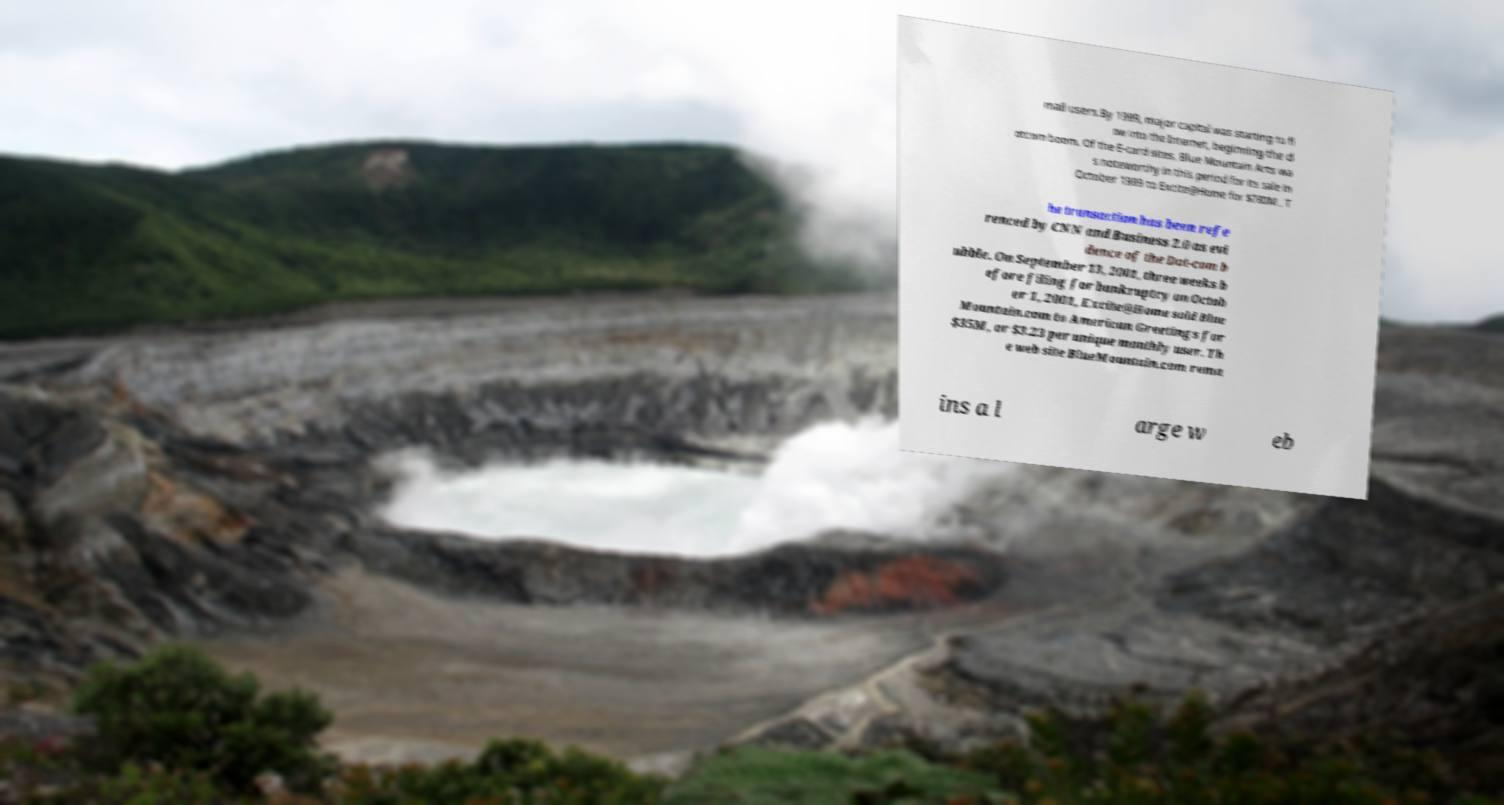Could you extract and type out the text from this image? mail users.By 1999, major capital was starting to fl ow into the Internet, beginning the d otcom boom. Of the E-card sites, Blue Mountain Arts wa s noteworthy in this period for its sale in October 1999 to Excite@Home for $780M . T he transaction has been refe renced by CNN and Business 2.0 as evi dence of the Dot-com b ubble. On September 13, 2001, three weeks b efore filing for bankruptcy on Octob er 1, 2001, Excite@Home sold Blue Mountain.com to American Greetings for $35M, or $3.23 per unique monthly user. Th e web site BlueMountain.com rema ins a l arge w eb 